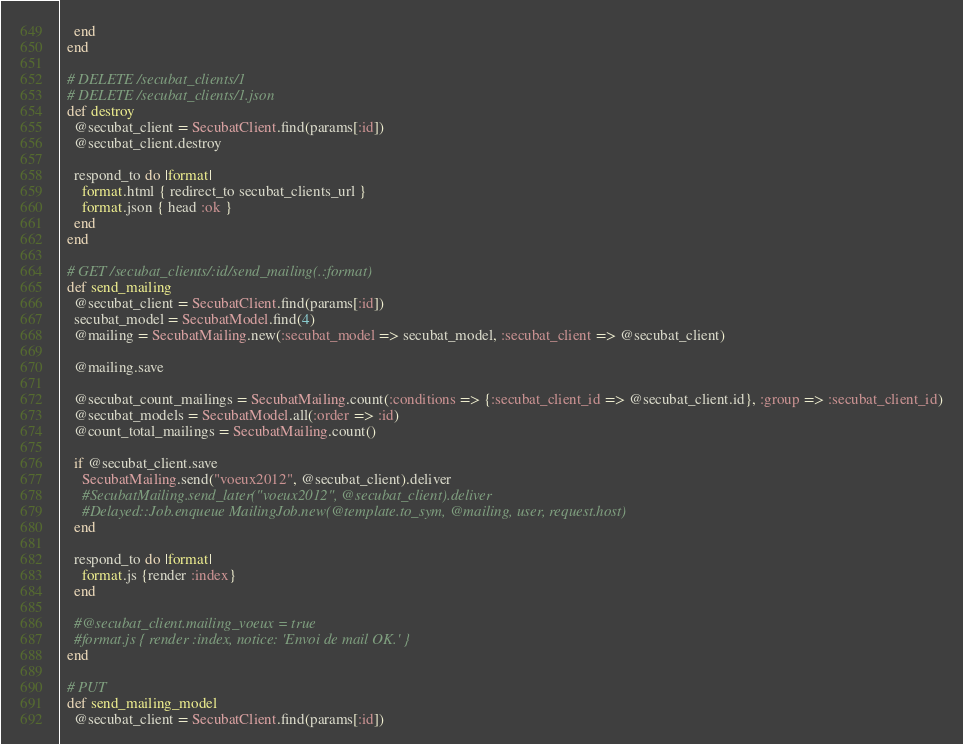Convert code to text. <code><loc_0><loc_0><loc_500><loc_500><_Ruby_>    end
  end

  # DELETE /secubat_clients/1
  # DELETE /secubat_clients/1.json
  def destroy
    @secubat_client = SecubatClient.find(params[:id])
    @secubat_client.destroy

    respond_to do |format|
      format.html { redirect_to secubat_clients_url }
      format.json { head :ok }
    end
  end

  # GET /secubat_clients/:id/send_mailing(.:format)
  def send_mailing
    @secubat_client = SecubatClient.find(params[:id])
    secubat_model = SecubatModel.find(4)
    @mailing = SecubatMailing.new(:secubat_model => secubat_model, :secubat_client => @secubat_client)

    @mailing.save

    @secubat_count_mailings = SecubatMailing.count(:conditions => {:secubat_client_id => @secubat_client.id}, :group => :secubat_client_id)
    @secubat_models = SecubatModel.all(:order => :id)
    @count_total_mailings = SecubatMailing.count()

    if @secubat_client.save
      SecubatMailing.send("voeux2012", @secubat_client).deliver
      #SecubatMailing.send_later("voeux2012", @secubat_client).deliver
      #Delayed::Job.enqueue MailingJob.new(@template.to_sym, @mailing, user, request.host)
    end

    respond_to do |format|
      format.js {render :index}
    end

    #@secubat_client.mailing_voeux = true
    #format.js { render :index, notice: 'Envoi de mail OK.' }
  end

  # PUT
  def send_mailing_model
    @secubat_client = SecubatClient.find(params[:id])</code> 